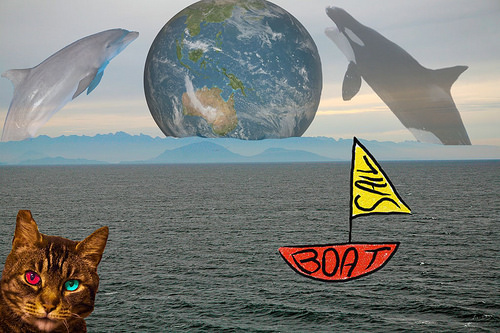<image>
Is the red eye on the cat? Yes. Looking at the image, I can see the red eye is positioned on top of the cat, with the cat providing support. Where is the world in relation to the mountain? Is it on the mountain? Yes. Looking at the image, I can see the world is positioned on top of the mountain, with the mountain providing support. 